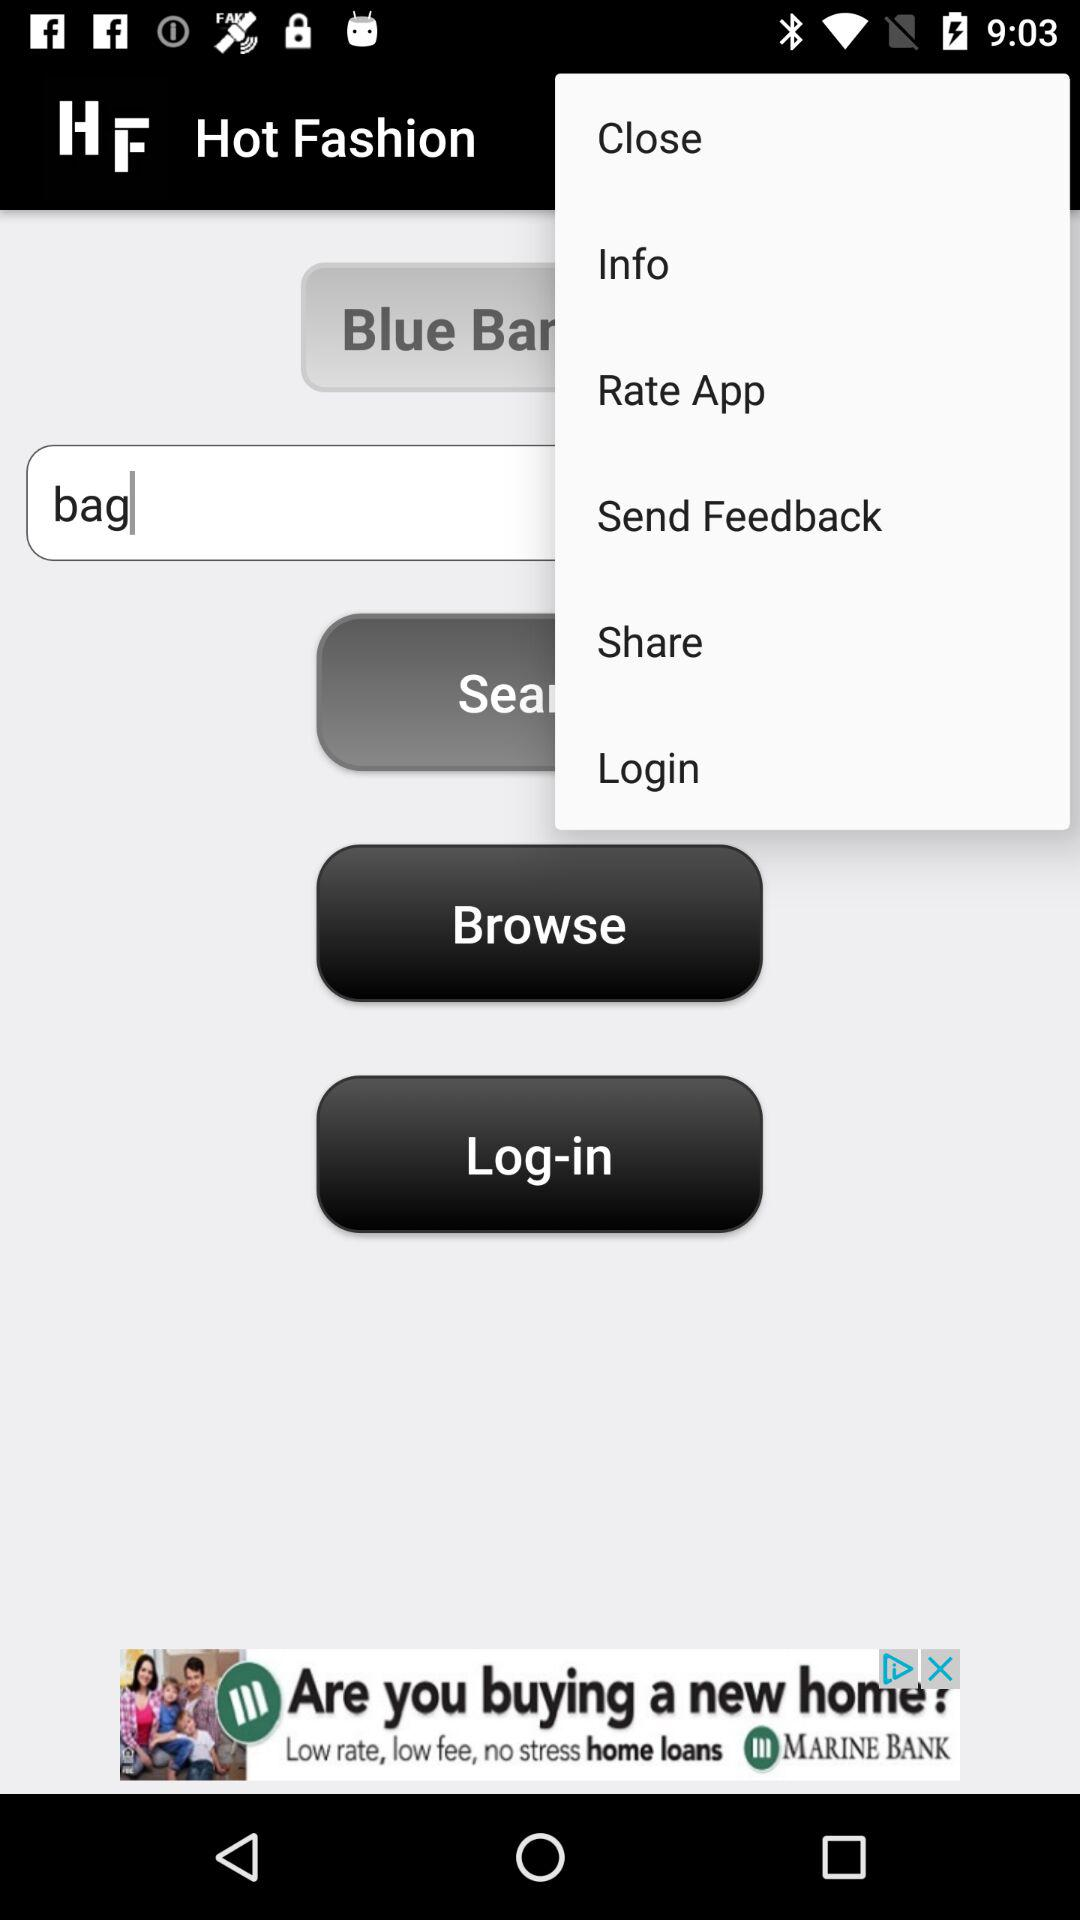What is the application name? The application name is "Hot Fashion". 